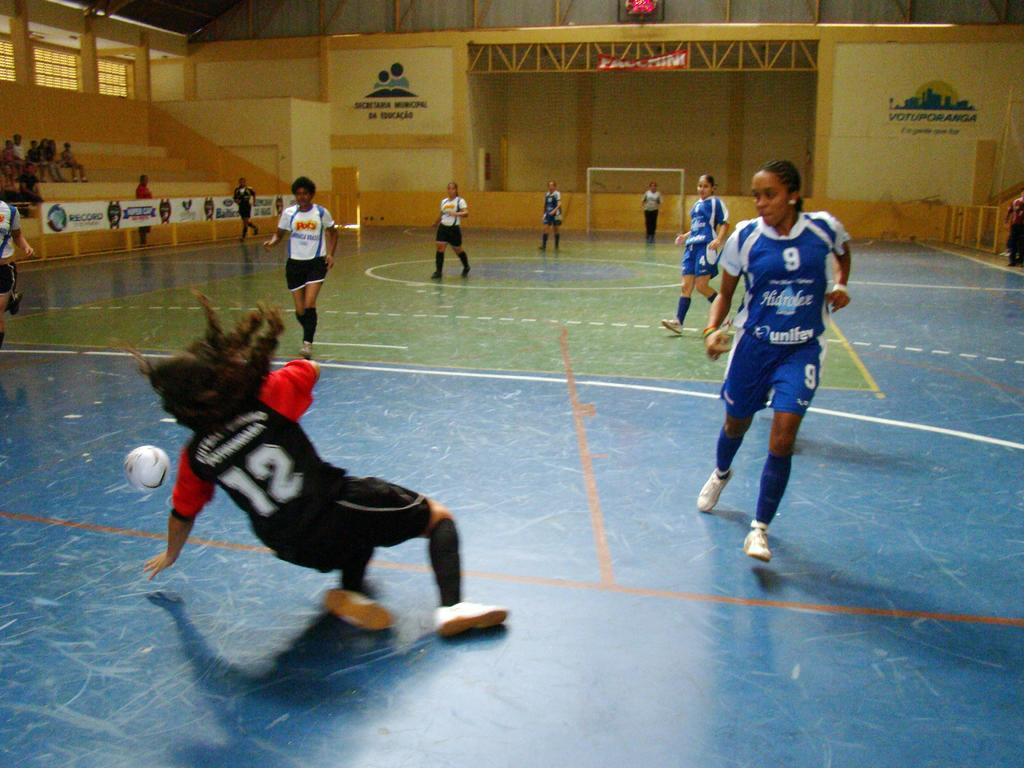<image>
Render a clear and concise summary of the photo. volleyball players with the numbers 12 and 9 on each of their jerseys 